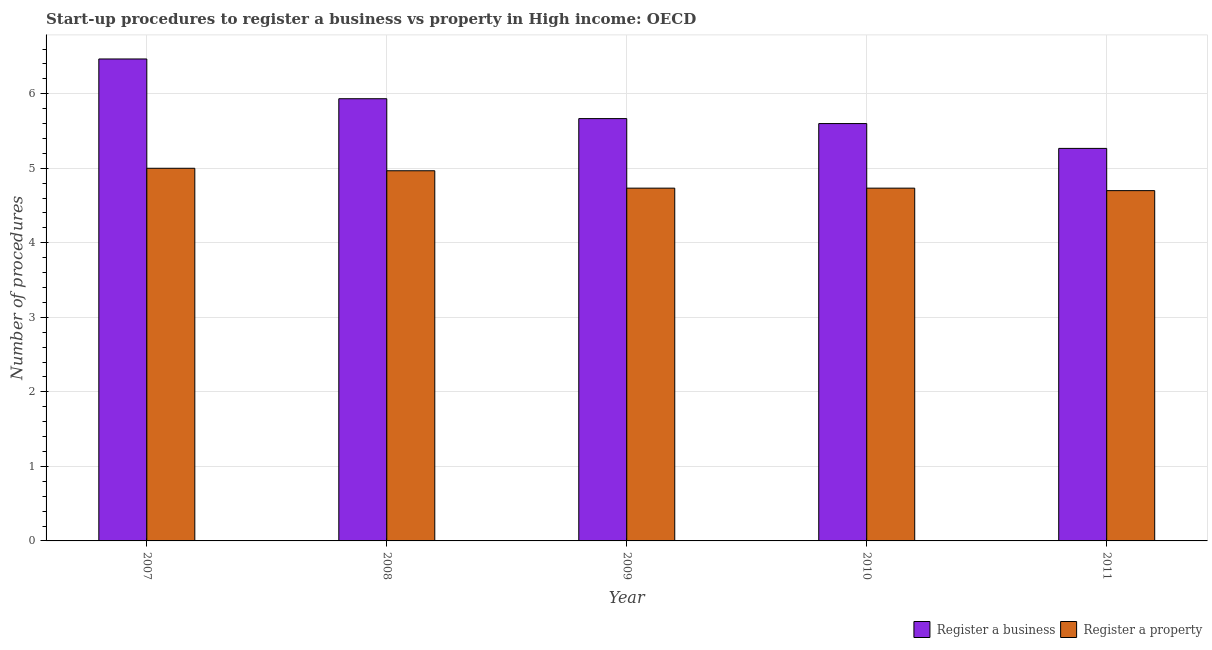Across all years, what is the maximum number of procedures to register a business?
Ensure brevity in your answer.  6.47. Across all years, what is the minimum number of procedures to register a business?
Your answer should be very brief. 5.27. What is the total number of procedures to register a business in the graph?
Provide a short and direct response. 28.93. What is the difference between the number of procedures to register a property in 2007 and that in 2010?
Your answer should be compact. 0.27. What is the difference between the number of procedures to register a business in 2011 and the number of procedures to register a property in 2008?
Your response must be concise. -0.67. What is the average number of procedures to register a business per year?
Ensure brevity in your answer.  5.79. In the year 2007, what is the difference between the number of procedures to register a property and number of procedures to register a business?
Provide a short and direct response. 0. What is the ratio of the number of procedures to register a business in 2007 to that in 2011?
Offer a terse response. 1.23. Is the number of procedures to register a property in 2009 less than that in 2010?
Make the answer very short. No. What is the difference between the highest and the second highest number of procedures to register a property?
Your response must be concise. 0.03. What is the difference between the highest and the lowest number of procedures to register a property?
Your answer should be compact. 0.3. Is the sum of the number of procedures to register a property in 2009 and 2011 greater than the maximum number of procedures to register a business across all years?
Ensure brevity in your answer.  Yes. What does the 2nd bar from the left in 2007 represents?
Give a very brief answer. Register a property. What does the 2nd bar from the right in 2011 represents?
Your answer should be compact. Register a business. How many years are there in the graph?
Ensure brevity in your answer.  5. What is the difference between two consecutive major ticks on the Y-axis?
Offer a very short reply. 1. Are the values on the major ticks of Y-axis written in scientific E-notation?
Give a very brief answer. No. How many legend labels are there?
Keep it short and to the point. 2. What is the title of the graph?
Make the answer very short. Start-up procedures to register a business vs property in High income: OECD. What is the label or title of the Y-axis?
Ensure brevity in your answer.  Number of procedures. What is the Number of procedures in Register a business in 2007?
Your response must be concise. 6.47. What is the Number of procedures of Register a business in 2008?
Your answer should be very brief. 5.93. What is the Number of procedures in Register a property in 2008?
Provide a succinct answer. 4.97. What is the Number of procedures of Register a business in 2009?
Give a very brief answer. 5.67. What is the Number of procedures of Register a property in 2009?
Give a very brief answer. 4.73. What is the Number of procedures in Register a property in 2010?
Offer a terse response. 4.73. What is the Number of procedures of Register a business in 2011?
Offer a terse response. 5.27. What is the Number of procedures of Register a property in 2011?
Your answer should be very brief. 4.7. Across all years, what is the maximum Number of procedures in Register a business?
Provide a succinct answer. 6.47. Across all years, what is the minimum Number of procedures in Register a business?
Your answer should be compact. 5.27. What is the total Number of procedures in Register a business in the graph?
Offer a very short reply. 28.93. What is the total Number of procedures of Register a property in the graph?
Your response must be concise. 24.13. What is the difference between the Number of procedures in Register a business in 2007 and that in 2008?
Provide a succinct answer. 0.53. What is the difference between the Number of procedures in Register a property in 2007 and that in 2008?
Provide a succinct answer. 0.03. What is the difference between the Number of procedures of Register a property in 2007 and that in 2009?
Offer a terse response. 0.27. What is the difference between the Number of procedures of Register a business in 2007 and that in 2010?
Your answer should be compact. 0.87. What is the difference between the Number of procedures in Register a property in 2007 and that in 2010?
Your answer should be very brief. 0.27. What is the difference between the Number of procedures of Register a business in 2007 and that in 2011?
Your response must be concise. 1.2. What is the difference between the Number of procedures of Register a property in 2007 and that in 2011?
Keep it short and to the point. 0.3. What is the difference between the Number of procedures in Register a business in 2008 and that in 2009?
Provide a succinct answer. 0.27. What is the difference between the Number of procedures of Register a property in 2008 and that in 2009?
Provide a succinct answer. 0.23. What is the difference between the Number of procedures in Register a business in 2008 and that in 2010?
Provide a succinct answer. 0.33. What is the difference between the Number of procedures of Register a property in 2008 and that in 2010?
Make the answer very short. 0.23. What is the difference between the Number of procedures of Register a business in 2008 and that in 2011?
Your response must be concise. 0.67. What is the difference between the Number of procedures in Register a property in 2008 and that in 2011?
Keep it short and to the point. 0.27. What is the difference between the Number of procedures of Register a business in 2009 and that in 2010?
Keep it short and to the point. 0.07. What is the difference between the Number of procedures of Register a property in 2009 and that in 2010?
Your response must be concise. 0. What is the difference between the Number of procedures in Register a business in 2010 and that in 2011?
Your answer should be very brief. 0.33. What is the difference between the Number of procedures of Register a business in 2007 and the Number of procedures of Register a property in 2009?
Your response must be concise. 1.73. What is the difference between the Number of procedures of Register a business in 2007 and the Number of procedures of Register a property in 2010?
Offer a terse response. 1.73. What is the difference between the Number of procedures of Register a business in 2007 and the Number of procedures of Register a property in 2011?
Ensure brevity in your answer.  1.77. What is the difference between the Number of procedures in Register a business in 2008 and the Number of procedures in Register a property in 2010?
Ensure brevity in your answer.  1.2. What is the difference between the Number of procedures in Register a business in 2008 and the Number of procedures in Register a property in 2011?
Keep it short and to the point. 1.23. What is the difference between the Number of procedures of Register a business in 2009 and the Number of procedures of Register a property in 2011?
Ensure brevity in your answer.  0.97. What is the difference between the Number of procedures in Register a business in 2010 and the Number of procedures in Register a property in 2011?
Your answer should be very brief. 0.9. What is the average Number of procedures of Register a business per year?
Your answer should be very brief. 5.79. What is the average Number of procedures of Register a property per year?
Offer a very short reply. 4.83. In the year 2007, what is the difference between the Number of procedures of Register a business and Number of procedures of Register a property?
Ensure brevity in your answer.  1.47. In the year 2008, what is the difference between the Number of procedures in Register a business and Number of procedures in Register a property?
Offer a very short reply. 0.97. In the year 2010, what is the difference between the Number of procedures in Register a business and Number of procedures in Register a property?
Your answer should be very brief. 0.87. In the year 2011, what is the difference between the Number of procedures in Register a business and Number of procedures in Register a property?
Ensure brevity in your answer.  0.57. What is the ratio of the Number of procedures of Register a business in 2007 to that in 2008?
Your response must be concise. 1.09. What is the ratio of the Number of procedures of Register a property in 2007 to that in 2008?
Make the answer very short. 1.01. What is the ratio of the Number of procedures in Register a business in 2007 to that in 2009?
Ensure brevity in your answer.  1.14. What is the ratio of the Number of procedures of Register a property in 2007 to that in 2009?
Offer a very short reply. 1.06. What is the ratio of the Number of procedures of Register a business in 2007 to that in 2010?
Make the answer very short. 1.15. What is the ratio of the Number of procedures of Register a property in 2007 to that in 2010?
Ensure brevity in your answer.  1.06. What is the ratio of the Number of procedures in Register a business in 2007 to that in 2011?
Offer a very short reply. 1.23. What is the ratio of the Number of procedures in Register a property in 2007 to that in 2011?
Offer a terse response. 1.06. What is the ratio of the Number of procedures in Register a business in 2008 to that in 2009?
Your answer should be very brief. 1.05. What is the ratio of the Number of procedures in Register a property in 2008 to that in 2009?
Offer a very short reply. 1.05. What is the ratio of the Number of procedures of Register a business in 2008 to that in 2010?
Give a very brief answer. 1.06. What is the ratio of the Number of procedures in Register a property in 2008 to that in 2010?
Offer a very short reply. 1.05. What is the ratio of the Number of procedures in Register a business in 2008 to that in 2011?
Provide a short and direct response. 1.13. What is the ratio of the Number of procedures of Register a property in 2008 to that in 2011?
Provide a succinct answer. 1.06. What is the ratio of the Number of procedures in Register a business in 2009 to that in 2010?
Your response must be concise. 1.01. What is the ratio of the Number of procedures of Register a property in 2009 to that in 2010?
Provide a short and direct response. 1. What is the ratio of the Number of procedures in Register a business in 2009 to that in 2011?
Your answer should be compact. 1.08. What is the ratio of the Number of procedures in Register a property in 2009 to that in 2011?
Provide a short and direct response. 1.01. What is the ratio of the Number of procedures in Register a business in 2010 to that in 2011?
Your answer should be compact. 1.06. What is the ratio of the Number of procedures in Register a property in 2010 to that in 2011?
Provide a short and direct response. 1.01. What is the difference between the highest and the second highest Number of procedures of Register a business?
Provide a short and direct response. 0.53. What is the difference between the highest and the lowest Number of procedures of Register a property?
Make the answer very short. 0.3. 